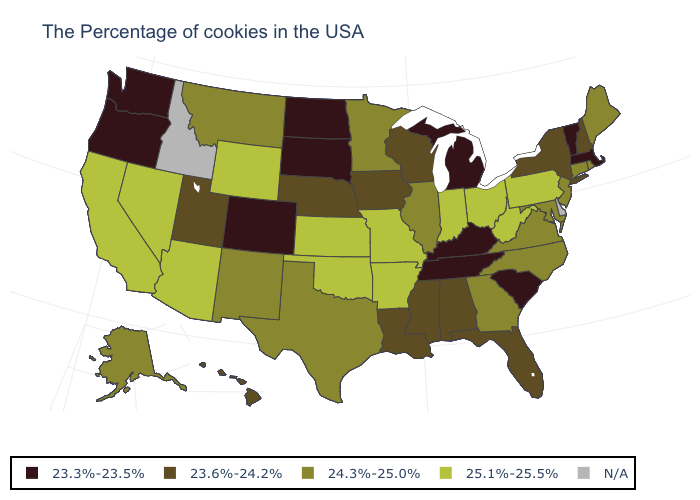What is the value of Washington?
Short answer required. 23.3%-23.5%. How many symbols are there in the legend?
Keep it brief. 5. Does the first symbol in the legend represent the smallest category?
Give a very brief answer. Yes. What is the value of Minnesota?
Give a very brief answer. 24.3%-25.0%. What is the value of Pennsylvania?
Answer briefly. 25.1%-25.5%. What is the value of Illinois?
Be succinct. 24.3%-25.0%. Does Kentucky have the lowest value in the South?
Give a very brief answer. Yes. Which states have the highest value in the USA?
Concise answer only. Pennsylvania, West Virginia, Ohio, Indiana, Missouri, Arkansas, Kansas, Oklahoma, Wyoming, Arizona, Nevada, California. What is the value of Missouri?
Write a very short answer. 25.1%-25.5%. Which states have the lowest value in the USA?
Be succinct. Massachusetts, Vermont, South Carolina, Michigan, Kentucky, Tennessee, South Dakota, North Dakota, Colorado, Washington, Oregon. Name the states that have a value in the range 23.6%-24.2%?
Be succinct. New Hampshire, New York, Florida, Alabama, Wisconsin, Mississippi, Louisiana, Iowa, Nebraska, Utah, Hawaii. Among the states that border Vermont , which have the lowest value?
Answer briefly. Massachusetts. What is the value of Oregon?
Quick response, please. 23.3%-23.5%. 